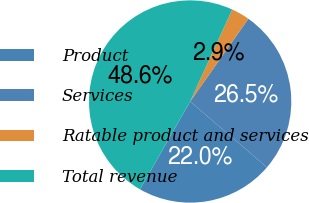Convert chart to OTSL. <chart><loc_0><loc_0><loc_500><loc_500><pie_chart><fcel>Product<fcel>Services<fcel>Ratable product and services<fcel>Total revenue<nl><fcel>21.96%<fcel>26.53%<fcel>2.93%<fcel>48.58%<nl></chart> 